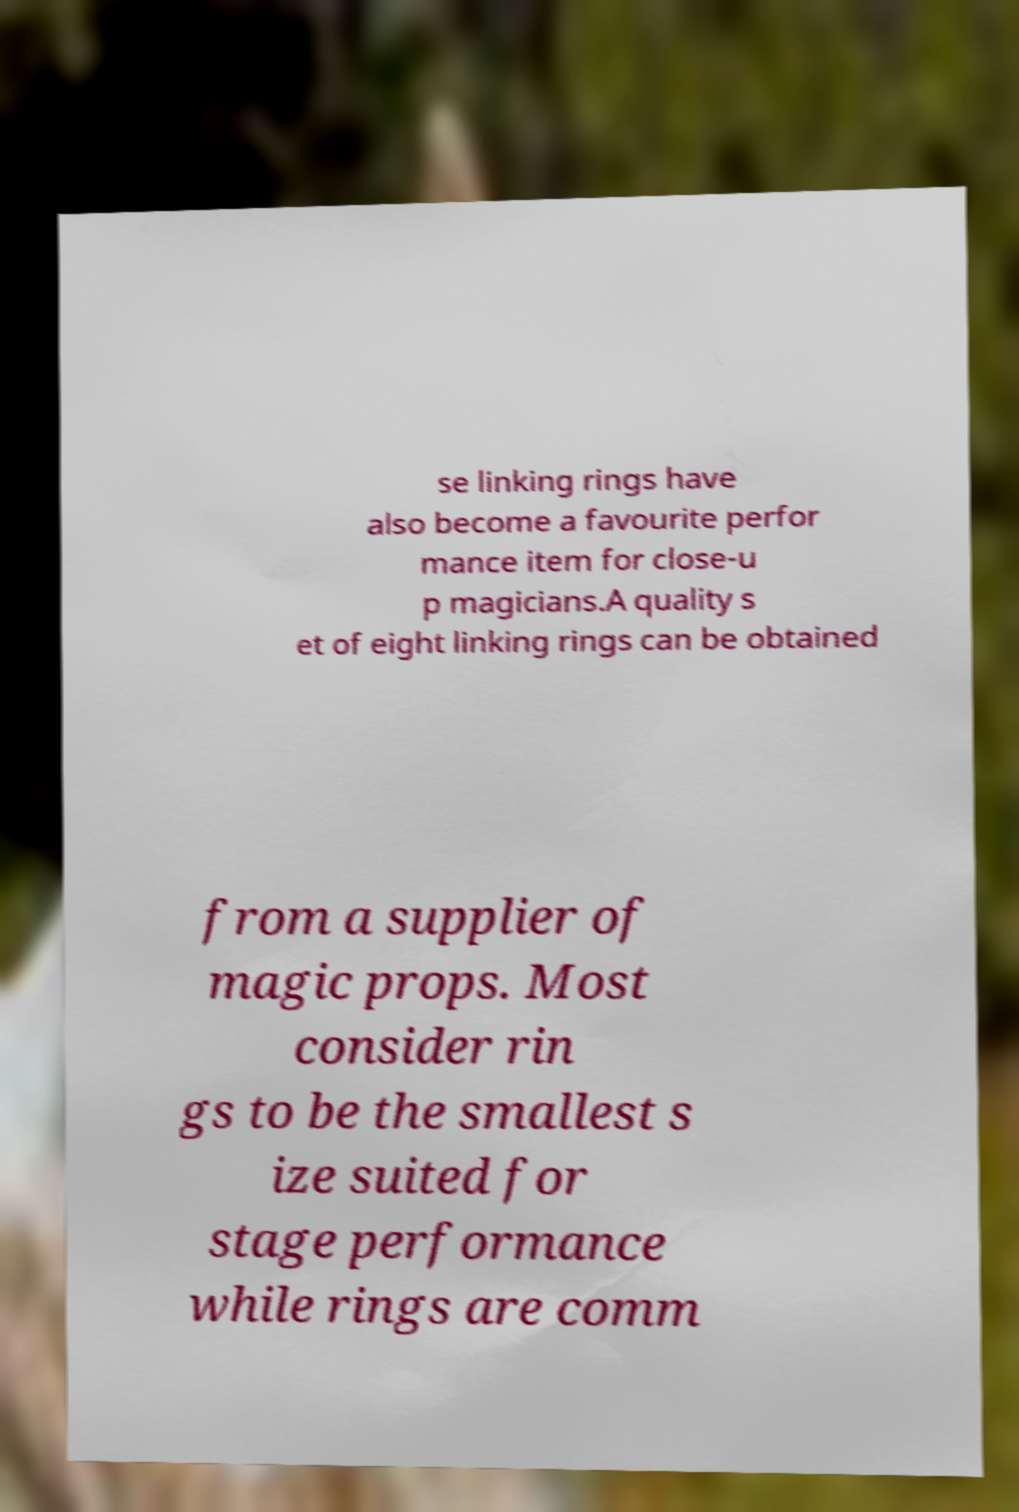Please identify and transcribe the text found in this image. se linking rings have also become a favourite perfor mance item for close-u p magicians.A quality s et of eight linking rings can be obtained from a supplier of magic props. Most consider rin gs to be the smallest s ize suited for stage performance while rings are comm 